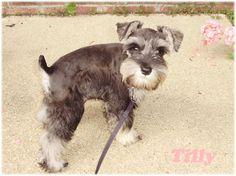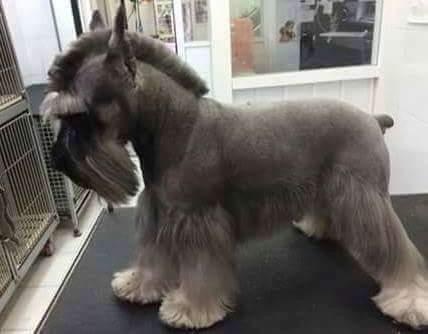The first image is the image on the left, the second image is the image on the right. For the images displayed, is the sentence "The dog in the image on the right is standing on all fours." factually correct? Answer yes or no. Yes. The first image is the image on the left, the second image is the image on the right. Evaluate the accuracy of this statement regarding the images: "One camera-gazing schnauzer is standing on all fours on a surface that looks like cement.". Is it true? Answer yes or no. Yes. 